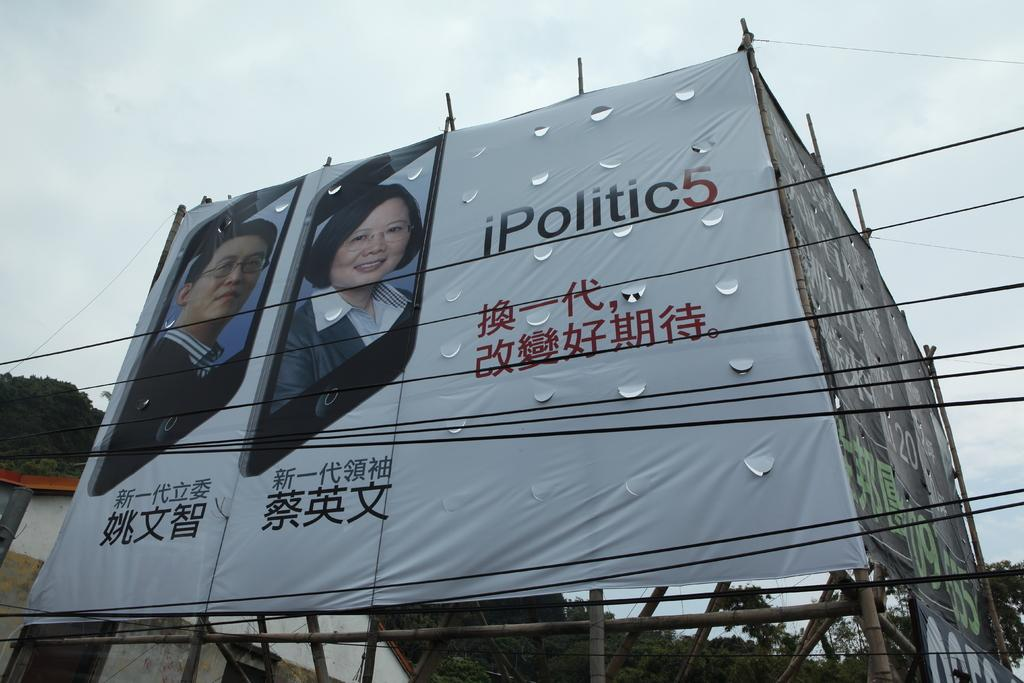What type of structures are present in the image? A: There are hoardings in the image. What else can be seen in the image besides the hoardings? There are cables and trees visible in the image. What is visible in the background of the image? The sky is visible in the background of the image. Can you tell me how many books the tree is reading in the image? There are no books or trees reading in the image; it features hoardings, cables, and trees. What type of stem is visible in the image? There is no stem present in the image. 